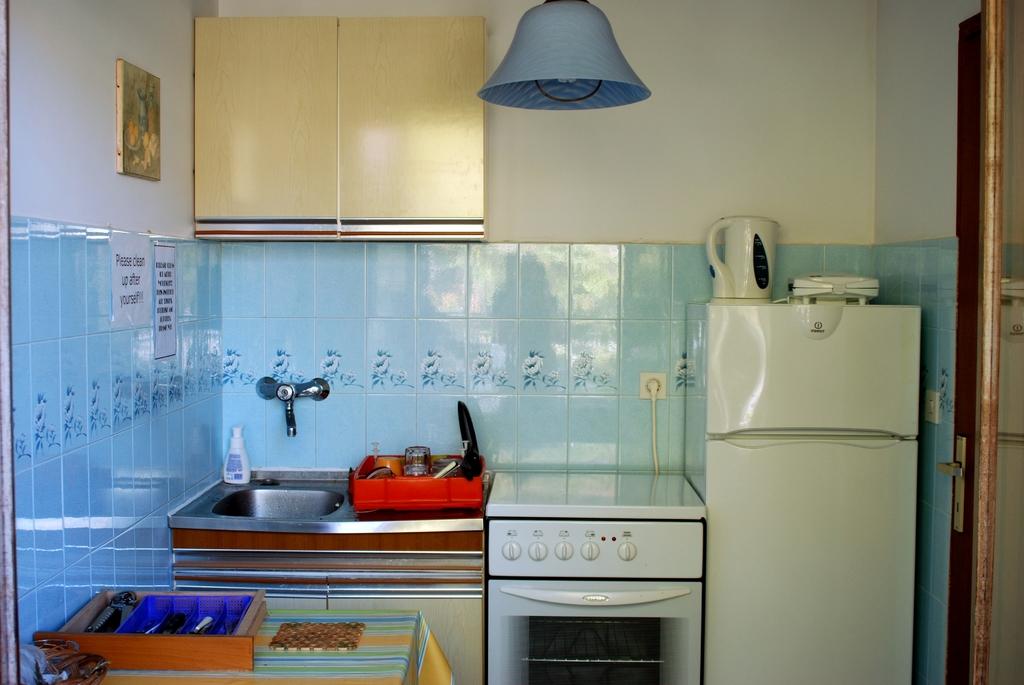What colors are the tiles/?
Make the answer very short. Answering does not require reading text in the image. 